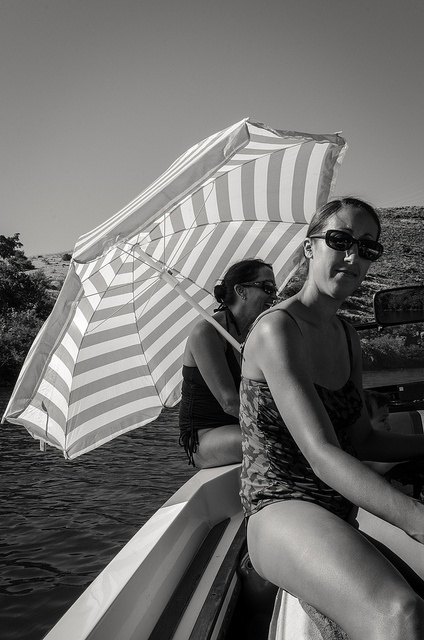Describe the objects in this image and their specific colors. I can see umbrella in gray, darkgray, and lightgray tones, people in gray, black, and darkgray tones, boat in gray, black, lightgray, and darkgray tones, and people in gray and black tones in this image. 